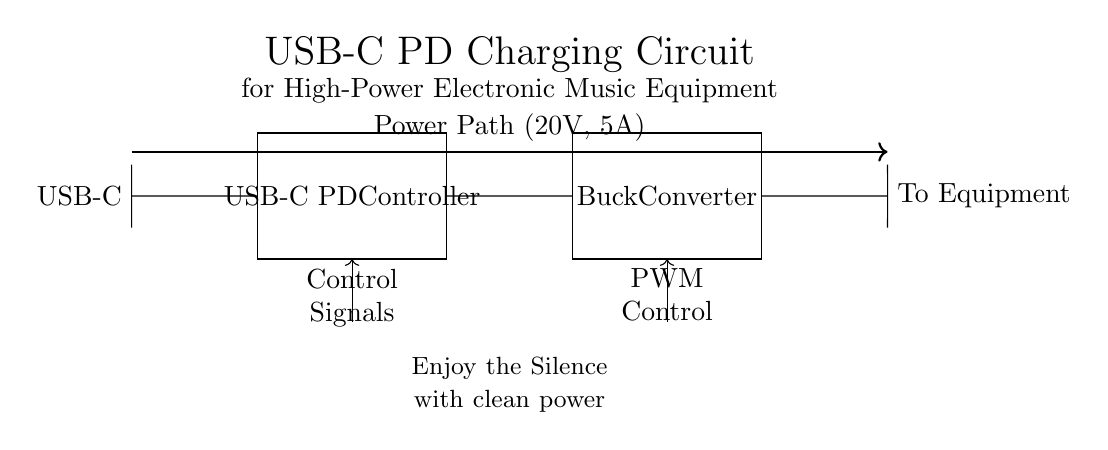What is the main function of the USB-C PD controller? The USB-C PD (Power Delivery) Controller manages the power flow between the USB-C connector and the rest of the circuit, facilitating negotiation for optimal voltage and current delivery.
Answer: Power management What is the output voltage of the power path? The power path indicates a voltage of 20V, which is specifically stated in the diagram.
Answer: 20V What type of converter is used in this circuit? The diagram specifies a buck converter, which steps down the voltage while regulating the output to suit the connected equipment.
Answer: Buck converter How much current can the power path handle? The circuit diagram indicates that the power path can handle a current of 5A, as noted directly on the diagram.
Answer: 5A What is the purpose of the control signals? Control signals are used for communication from the USB-C PD controller to the buck converter, allowing it to adjust output according to the equipment's needs.
Answer: Communication What kind of equipment does this circuit power? The output connects directly to "To Equipment", indicating that the circuit is meant to power high-power electronic music equipment.
Answer: Electronic music equipment What does the Depeche Mode reference imply in this context? The reference "Enjoy the Silence" creatively implies that clean power from this charging circuit is crucial for optimal performance in electronic music, creating a silent background for audio production.
Answer: Clean power for audio 